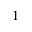<formula> <loc_0><loc_0><loc_500><loc_500>1</formula> 